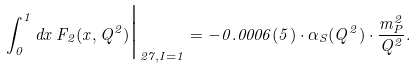<formula> <loc_0><loc_0><loc_500><loc_500>\int _ { 0 } ^ { 1 } d x \, F _ { 2 } ( x , Q ^ { 2 } ) \Big | _ { { 2 7 } , I = 1 } = - 0 . 0 0 0 6 ( 5 ) \cdot \alpha _ { S } ( Q ^ { 2 } ) \cdot \frac { m _ { P } ^ { 2 } } { Q ^ { 2 } } .</formula> 